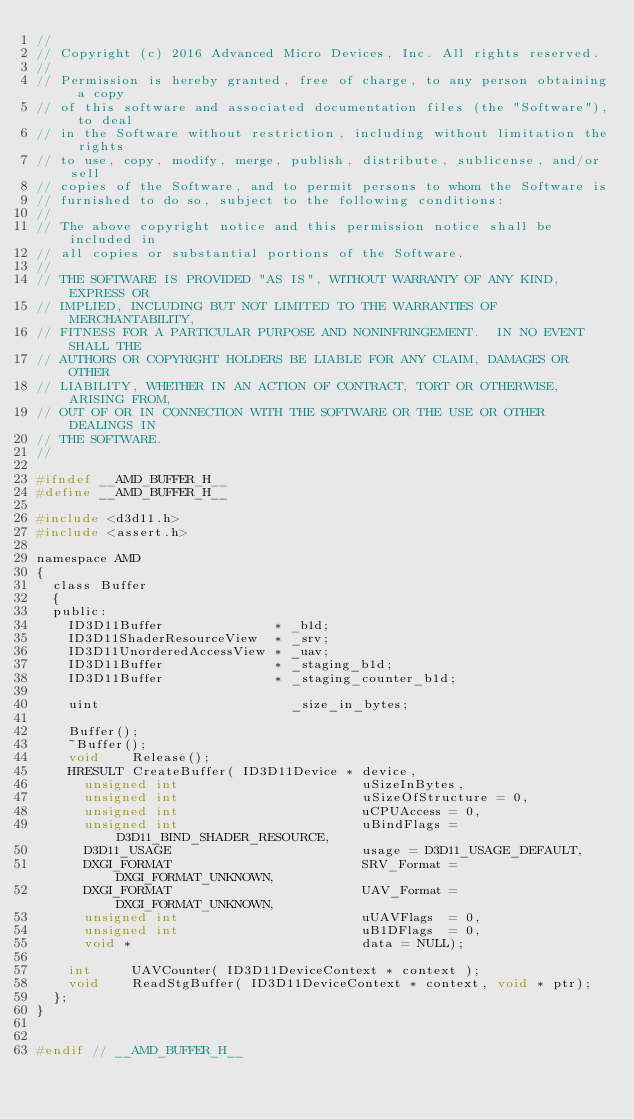Convert code to text. <code><loc_0><loc_0><loc_500><loc_500><_C_>//
// Copyright (c) 2016 Advanced Micro Devices, Inc. All rights reserved.
//
// Permission is hereby granted, free of charge, to any person obtaining a copy
// of this software and associated documentation files (the "Software"), to deal
// in the Software without restriction, including without limitation the rights
// to use, copy, modify, merge, publish, distribute, sublicense, and/or sell
// copies of the Software, and to permit persons to whom the Software is
// furnished to do so, subject to the following conditions:
//
// The above copyright notice and this permission notice shall be included in
// all copies or substantial portions of the Software.
//
// THE SOFTWARE IS PROVIDED "AS IS", WITHOUT WARRANTY OF ANY KIND, EXPRESS OR
// IMPLIED, INCLUDING BUT NOT LIMITED TO THE WARRANTIES OF MERCHANTABILITY,
// FITNESS FOR A PARTICULAR PURPOSE AND NONINFRINGEMENT.  IN NO EVENT SHALL THE
// AUTHORS OR COPYRIGHT HOLDERS BE LIABLE FOR ANY CLAIM, DAMAGES OR OTHER
// LIABILITY, WHETHER IN AN ACTION OF CONTRACT, TORT OR OTHERWISE, ARISING FROM,
// OUT OF OR IN CONNECTION WITH THE SOFTWARE OR THE USE OR OTHER DEALINGS IN
// THE SOFTWARE.
//

#ifndef __AMD_BUFFER_H__
#define __AMD_BUFFER_H__

#include <d3d11.h>
#include <assert.h>

namespace AMD
{
  class Buffer
  {
  public:
    ID3D11Buffer              * _b1d;
    ID3D11ShaderResourceView  * _srv;
    ID3D11UnorderedAccessView * _uav;
    ID3D11Buffer              * _staging_b1d;
    ID3D11Buffer              * _staging_counter_b1d;

    uint                        _size_in_bytes;

    Buffer();
    ~Buffer();
    void    Release();
    HRESULT CreateBuffer( ID3D11Device * device,
      unsigned int                       uSizeInBytes,
      unsigned int                       uSizeOfStructure = 0,
      unsigned int                       uCPUAccess = 0,
      unsigned int                       uBindFlags = D3D11_BIND_SHADER_RESOURCE,
      D3D11_USAGE                        usage = D3D11_USAGE_DEFAULT,
      DXGI_FORMAT                        SRV_Format = DXGI_FORMAT_UNKNOWN,
      DXGI_FORMAT                        UAV_Format = DXGI_FORMAT_UNKNOWN,
      unsigned int                       uUAVFlags  = 0,
      unsigned int                       uB1DFlags  = 0,
      void *                             data = NULL);

    int     UAVCounter( ID3D11DeviceContext * context );
    void    ReadStgBuffer( ID3D11DeviceContext * context, void * ptr);
  };
}


#endif // __AMD_BUFFER_H__</code> 